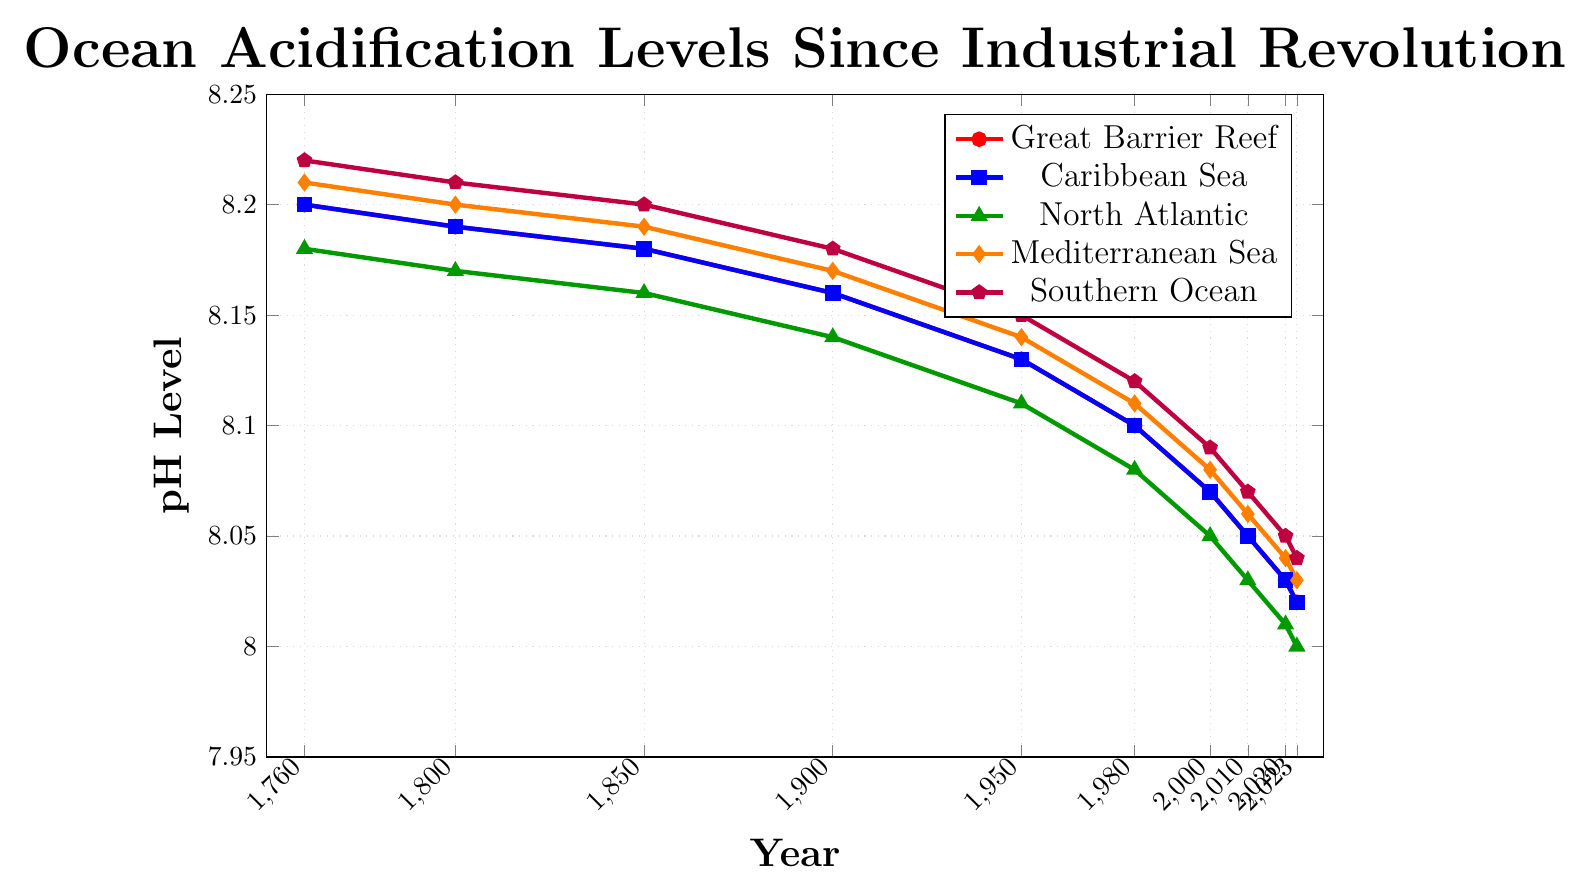What is the trend of pH levels in the Great Barrier Reef from 1760 to 2023? The pH levels in the Great Barrier Reef show a downward trend from 8.2 in 1760 to 8.02 in 2023. This indicates increasing ocean acidification over time.
Answer: Downward trend Which marine ecosystem had the highest pH level consistently since 1760? The Southern Ocean consistently had the highest pH levels, starting at 8.22 in 1760 and ending at 8.04 in 2023.
Answer: Southern Ocean Compare the pH levels of the North Atlantic and Mediterranean Sea in 2020. Which was higher? In 2020, the pH level in the North Atlantic was 8.01, whereas in the Mediterranean Sea, it was 8.04. Therefore, the Mediterranean Sea had a higher pH level.
Answer: Mediterranean Sea What is the average pH level of the Caribbean Sea from 1760 to 2023? Summing up the pH levels for the Caribbean Sea across the years: 8.2 + 8.19 + 8.18 + 8.16 + 8.13 + 8.1 + 8.07 + 8.05 + 8.03 + 8.02 = 81.13. Dividing by the number of data points (10), we get an average of 81.13 / 10 = 8.113.
Answer: 8.113 Between which years did the Southern Ocean experience the most significant drop in pH levels? By comparing the differences between consecutive years: checking (8.22 - 8.21)=0.01, (8.21 - 8.2)=0.01, (8.2 - 8.18)=0.02, (8.18 - 8.15)=0.03, (8.15 - 8.12)=0.03, (8.12 - 8.09)=0.03, (8.09 - 8.07)=0.02, (8.07 - 8.05)=0.02, (8.05 - 8.04)=0.01. The largest drops were from 1900 to 1950, 1950 to 1980, and 1980 to 2000, each 0.03.
Answer: 1900 to 1950, 1950 to 1980, and 1980 to 2000 What was the pH level in the Mediterranean Sea in 1980, and how does it compare to that in 1900? The pH level in the Mediterranean Sea in 1980 was 8.11, and in 1900, it was 8.17. Comparing these levels, the pH decreased by 0.06.
Answer: 8.11; decreased by 0.06 Which ecosystem had the lowest pH level in 2023? In 2023, the pH levels were: Great Barrier Reef - 8.02, Caribbean Sea - 8.02, North Atlantic - 8.0, Mediterranean Sea - 8.03, Southern Ocean - 8.04. The North Atlantic had the lowest pH level of 8.0.
Answer: North Atlantic How much did the pH of the Great Barrier Reef drop between 1760 and 2000? The pH level of the Great Barrier Reef was 8.2 in 1760 and 8.07 in 2000. The drop in pH is 8.2 - 8.07 = 0.13.
Answer: 0.13 What visual indicator is used to represent the North Atlantic in the chart? The North Atlantic is represented by green triangular markers on the chart.
Answer: Green triangles 